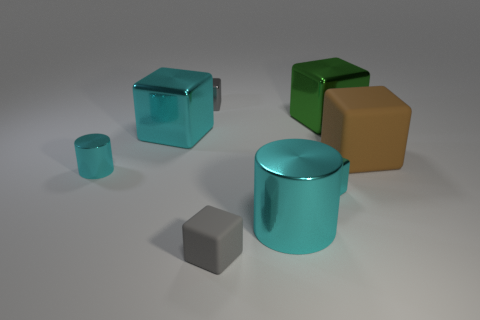Subtract all tiny cyan shiny cubes. How many cubes are left? 5 Subtract all yellow cylinders. How many cyan cubes are left? 2 Add 1 big blue things. How many objects exist? 9 Subtract all brown blocks. How many blocks are left? 5 Subtract 1 cylinders. How many cylinders are left? 1 Add 1 large balls. How many large balls exist? 1 Subtract 0 yellow cubes. How many objects are left? 8 Subtract all cylinders. How many objects are left? 6 Subtract all purple blocks. Subtract all cyan balls. How many blocks are left? 6 Subtract all large blue metal spheres. Subtract all cyan metal things. How many objects are left? 4 